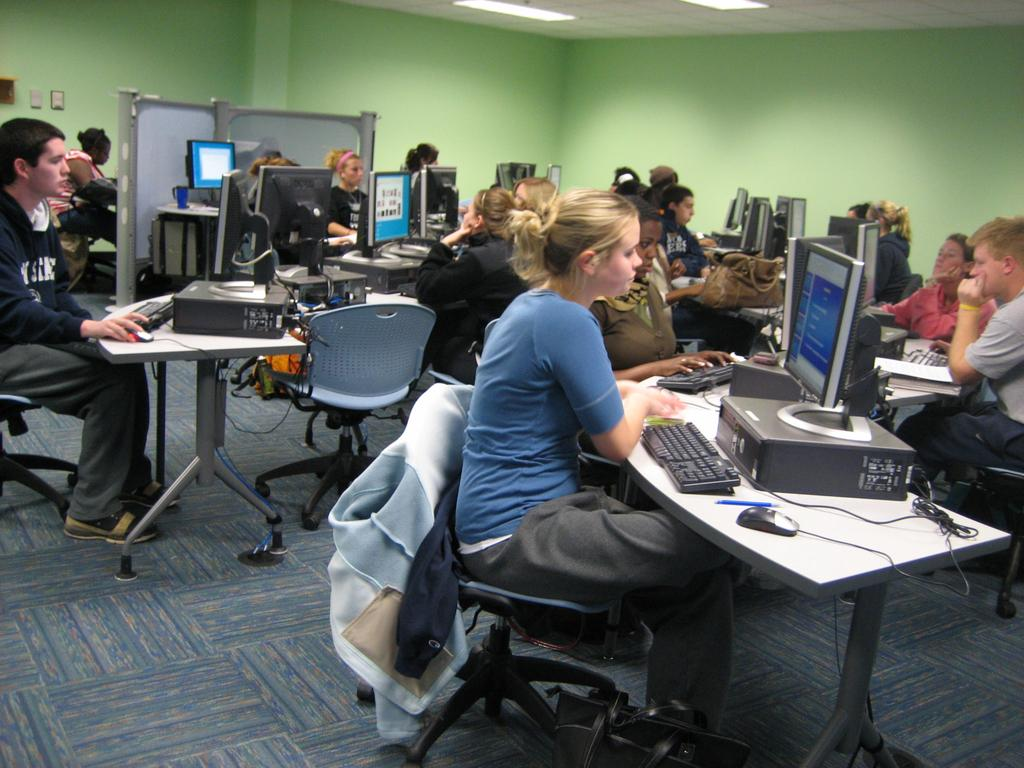Who is present in the image? There are people in the image. Where are the people located? The people are sitting in a room. What are the people doing in the room? The people are operating computers. What type of silk fabric is draped over the brass spotlight in the image? There is no silk fabric or brass spotlight present in the image. 